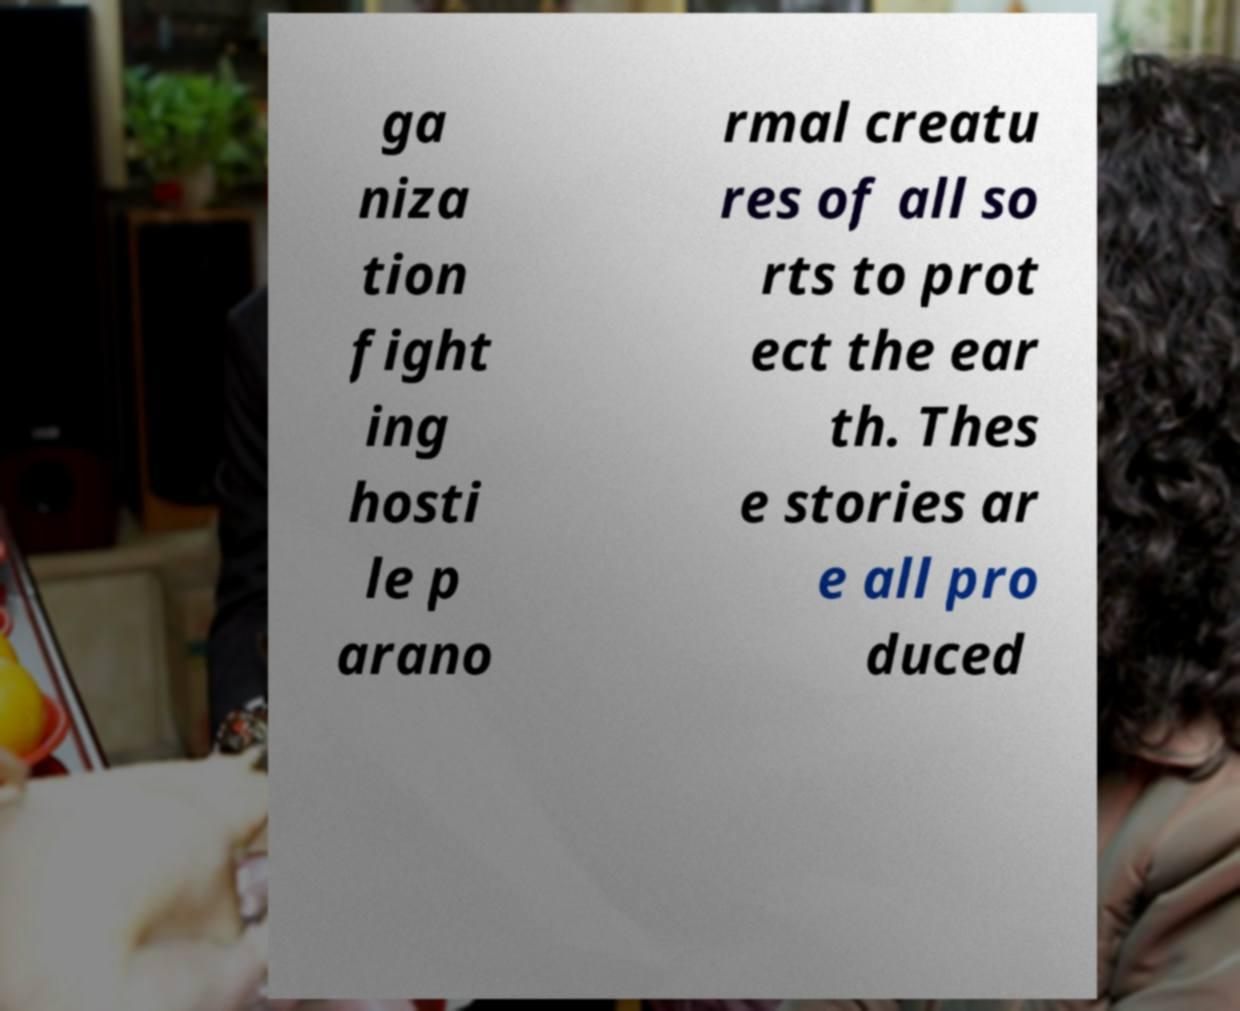Can you accurately transcribe the text from the provided image for me? ga niza tion fight ing hosti le p arano rmal creatu res of all so rts to prot ect the ear th. Thes e stories ar e all pro duced 